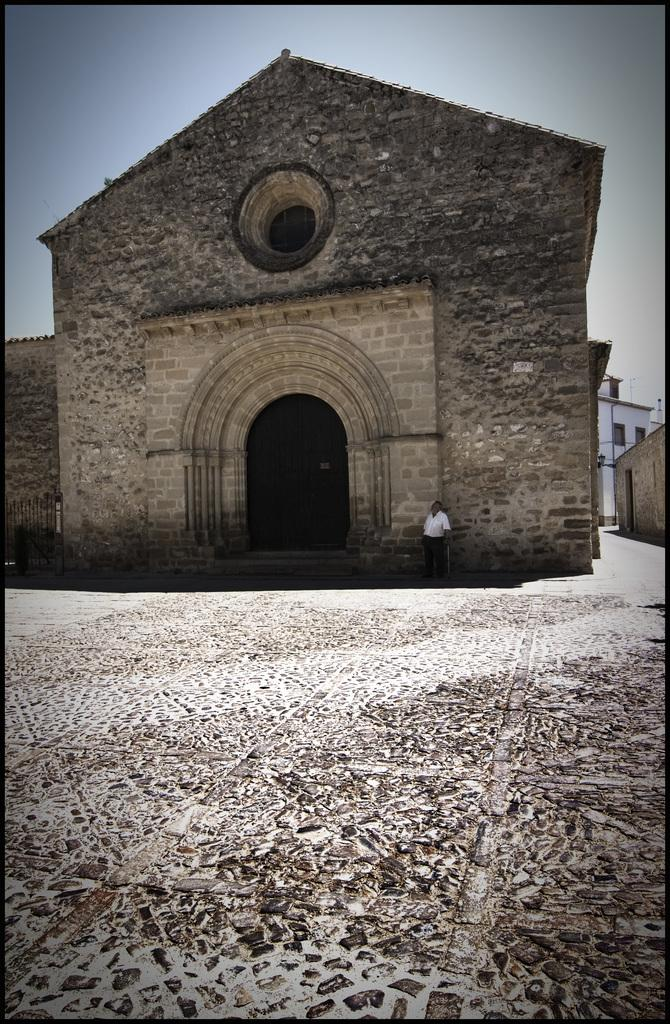What is located in the center of the image? There are buildings in the center of the image. Can you describe the person in the image? There is a man standing in the front of the image. What type of books can be seen in the library in the image? There is no library present in the image. What is the opinion of the bird in the image? There is no bird present in the image. 